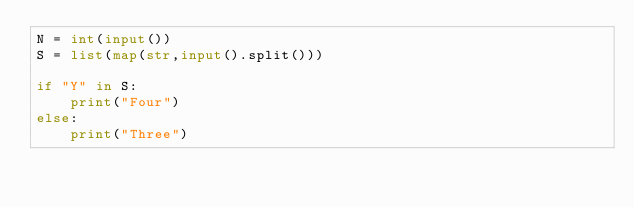<code> <loc_0><loc_0><loc_500><loc_500><_Python_>N = int(input())
S = list(map(str,input().split()))

if "Y" in S:
    print("Four")
else:
    print("Three")</code> 